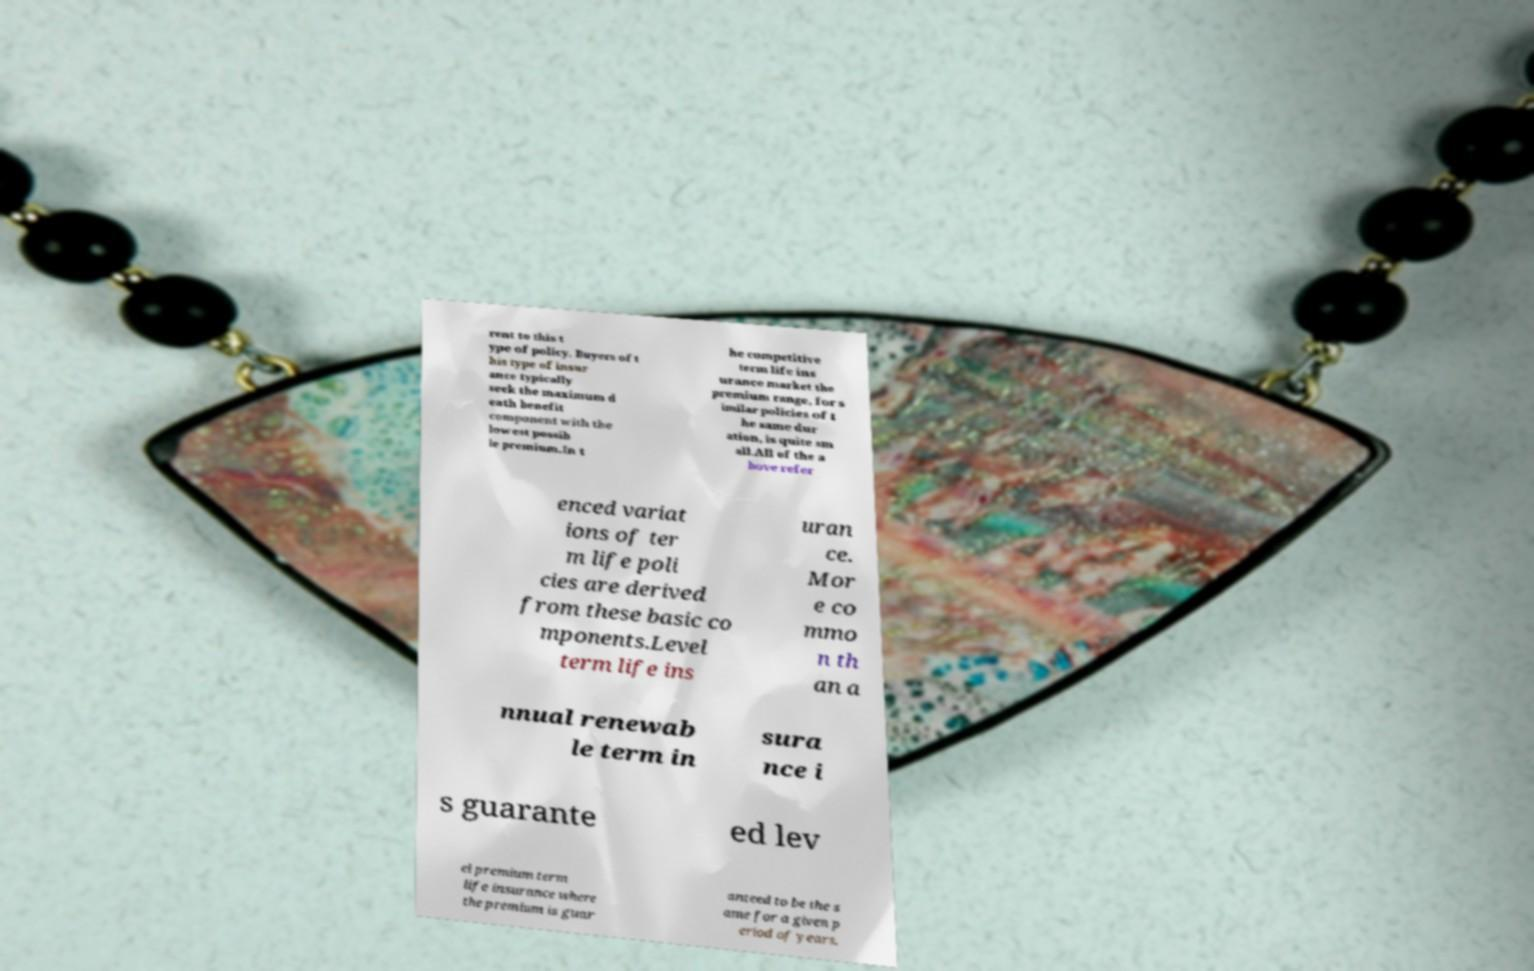There's text embedded in this image that I need extracted. Can you transcribe it verbatim? rent to this t ype of policy. Buyers of t his type of insur ance typically seek the maximum d eath benefit component with the lowest possib le premium.In t he competitive term life ins urance market the premium range, for s imilar policies of t he same dur ation, is quite sm all.All of the a bove refer enced variat ions of ter m life poli cies are derived from these basic co mponents.Level term life ins uran ce. Mor e co mmo n th an a nnual renewab le term in sura nce i s guarante ed lev el premium term life insurance where the premium is guar anteed to be the s ame for a given p eriod of years. 